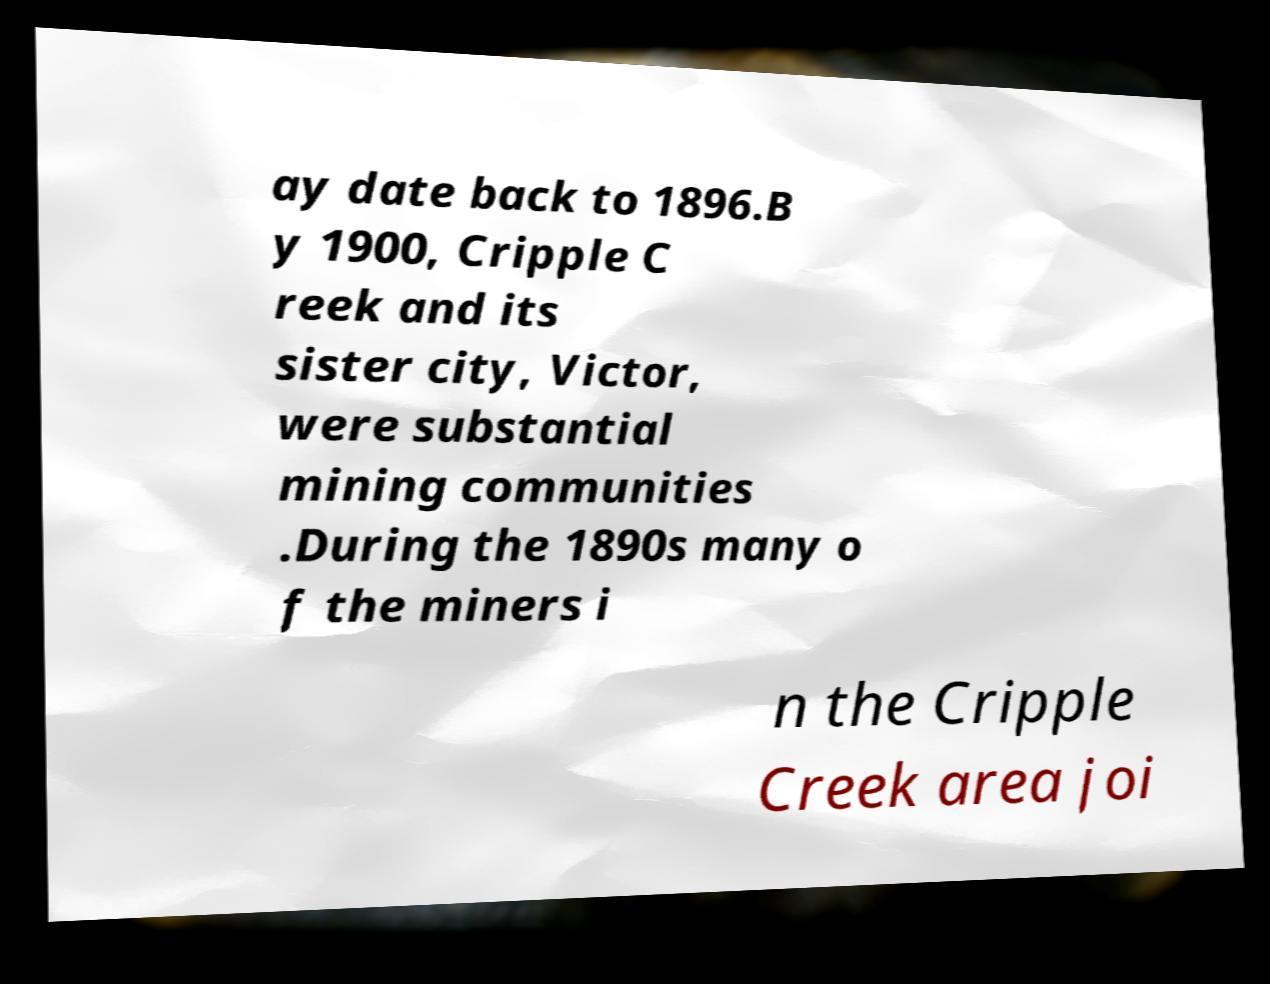Could you assist in decoding the text presented in this image and type it out clearly? ay date back to 1896.B y 1900, Cripple C reek and its sister city, Victor, were substantial mining communities .During the 1890s many o f the miners i n the Cripple Creek area joi 